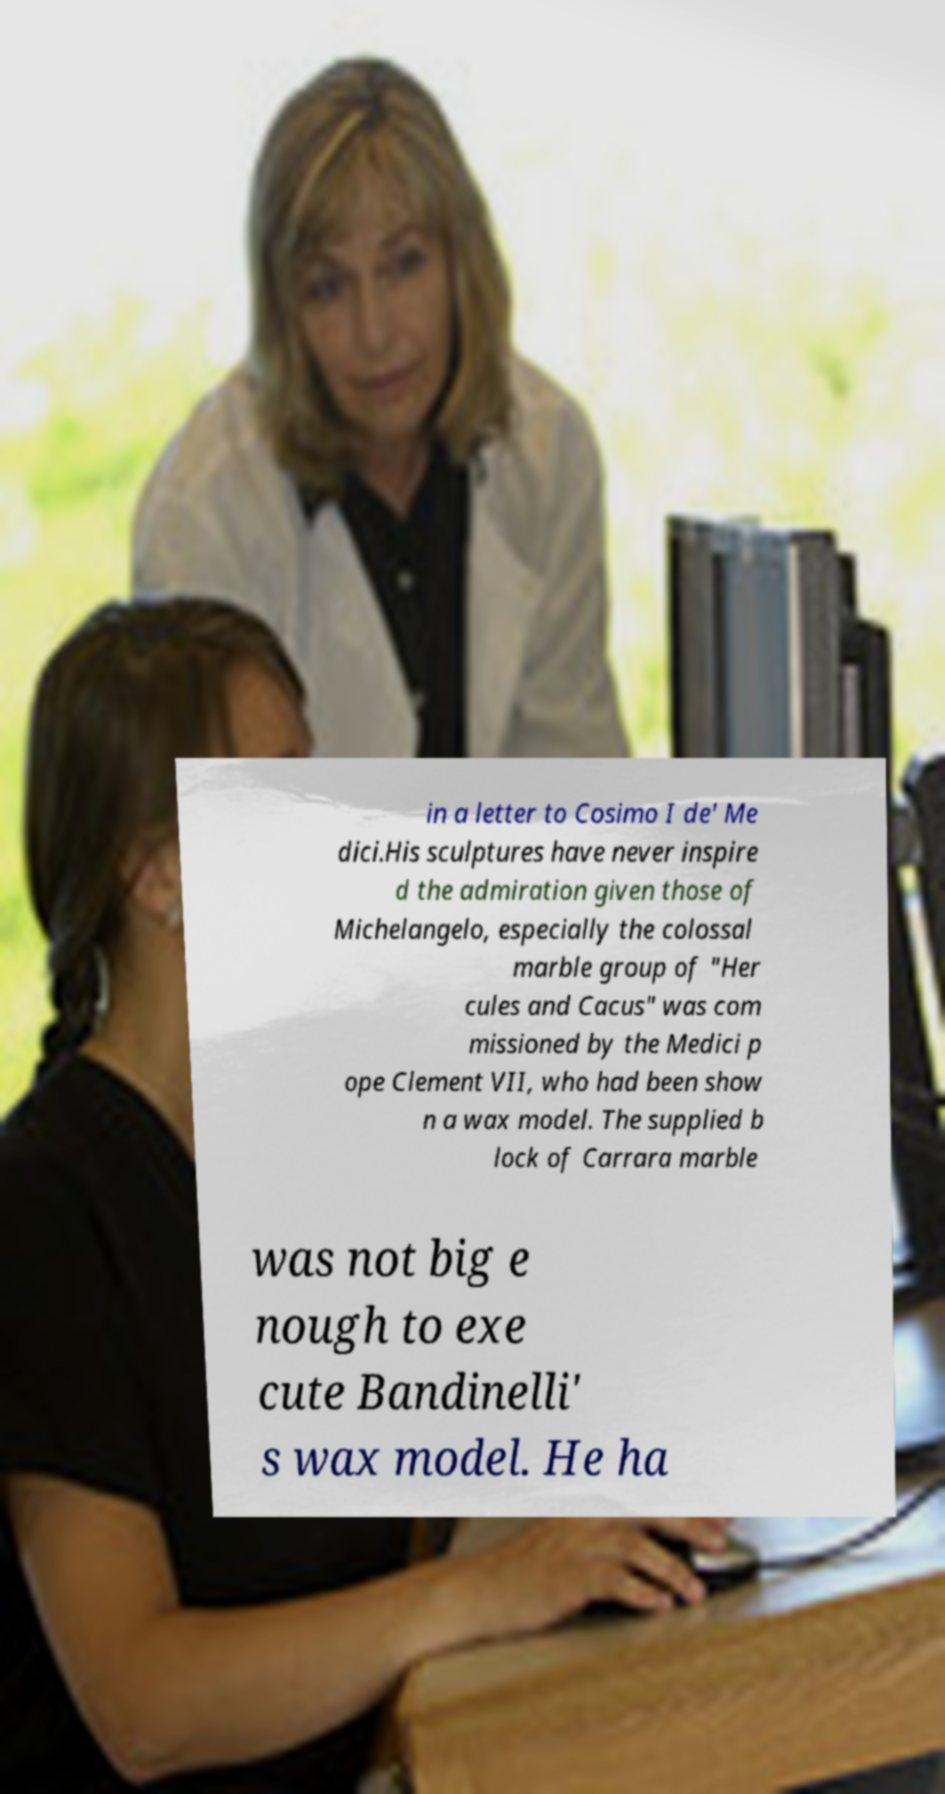For documentation purposes, I need the text within this image transcribed. Could you provide that? in a letter to Cosimo I de' Me dici.His sculptures have never inspire d the admiration given those of Michelangelo, especially the colossal marble group of "Her cules and Cacus" was com missioned by the Medici p ope Clement VII, who had been show n a wax model. The supplied b lock of Carrara marble was not big e nough to exe cute Bandinelli' s wax model. He ha 